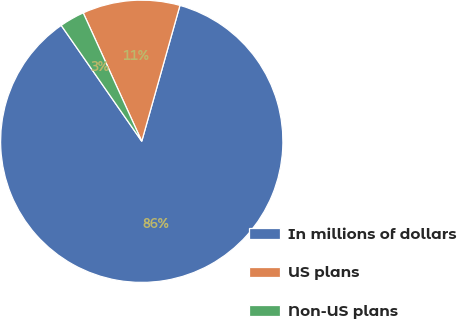<chart> <loc_0><loc_0><loc_500><loc_500><pie_chart><fcel>In millions of dollars<fcel>US plans<fcel>Non-US plans<nl><fcel>85.97%<fcel>11.17%<fcel>2.86%<nl></chart> 